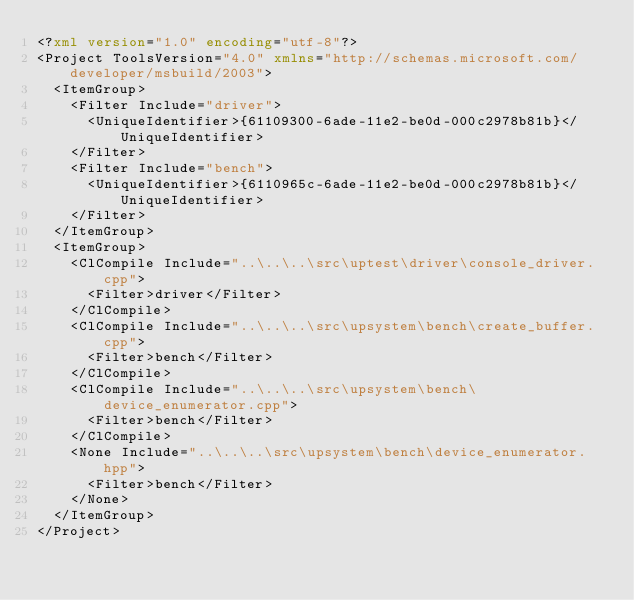<code> <loc_0><loc_0><loc_500><loc_500><_XML_><?xml version="1.0" encoding="utf-8"?>
<Project ToolsVersion="4.0" xmlns="http://schemas.microsoft.com/developer/msbuild/2003">
  <ItemGroup>
    <Filter Include="driver">
      <UniqueIdentifier>{61109300-6ade-11e2-be0d-000c2978b81b}</UniqueIdentifier>
    </Filter>
    <Filter Include="bench">
      <UniqueIdentifier>{6110965c-6ade-11e2-be0d-000c2978b81b}</UniqueIdentifier>
    </Filter>
  </ItemGroup>
  <ItemGroup>
    <ClCompile Include="..\..\..\src\uptest\driver\console_driver.cpp">
      <Filter>driver</Filter>
    </ClCompile>
    <ClCompile Include="..\..\..\src\upsystem\bench\create_buffer.cpp">
      <Filter>bench</Filter>
    </ClCompile>
    <ClCompile Include="..\..\..\src\upsystem\bench\device_enumerator.cpp">
      <Filter>bench</Filter>
    </ClCompile>
    <None Include="..\..\..\src\upsystem\bench\device_enumerator.hpp">
      <Filter>bench</Filter>
    </None>
  </ItemGroup>
</Project>
</code> 